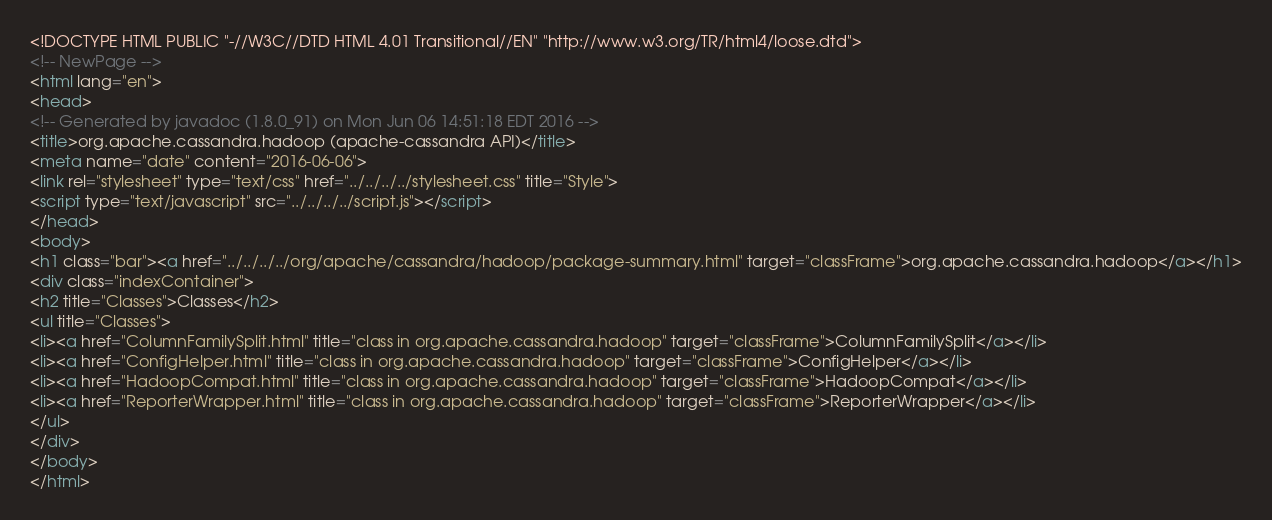<code> <loc_0><loc_0><loc_500><loc_500><_HTML_><!DOCTYPE HTML PUBLIC "-//W3C//DTD HTML 4.01 Transitional//EN" "http://www.w3.org/TR/html4/loose.dtd">
<!-- NewPage -->
<html lang="en">
<head>
<!-- Generated by javadoc (1.8.0_91) on Mon Jun 06 14:51:18 EDT 2016 -->
<title>org.apache.cassandra.hadoop (apache-cassandra API)</title>
<meta name="date" content="2016-06-06">
<link rel="stylesheet" type="text/css" href="../../../../stylesheet.css" title="Style">
<script type="text/javascript" src="../../../../script.js"></script>
</head>
<body>
<h1 class="bar"><a href="../../../../org/apache/cassandra/hadoop/package-summary.html" target="classFrame">org.apache.cassandra.hadoop</a></h1>
<div class="indexContainer">
<h2 title="Classes">Classes</h2>
<ul title="Classes">
<li><a href="ColumnFamilySplit.html" title="class in org.apache.cassandra.hadoop" target="classFrame">ColumnFamilySplit</a></li>
<li><a href="ConfigHelper.html" title="class in org.apache.cassandra.hadoop" target="classFrame">ConfigHelper</a></li>
<li><a href="HadoopCompat.html" title="class in org.apache.cassandra.hadoop" target="classFrame">HadoopCompat</a></li>
<li><a href="ReporterWrapper.html" title="class in org.apache.cassandra.hadoop" target="classFrame">ReporterWrapper</a></li>
</ul>
</div>
</body>
</html>
</code> 